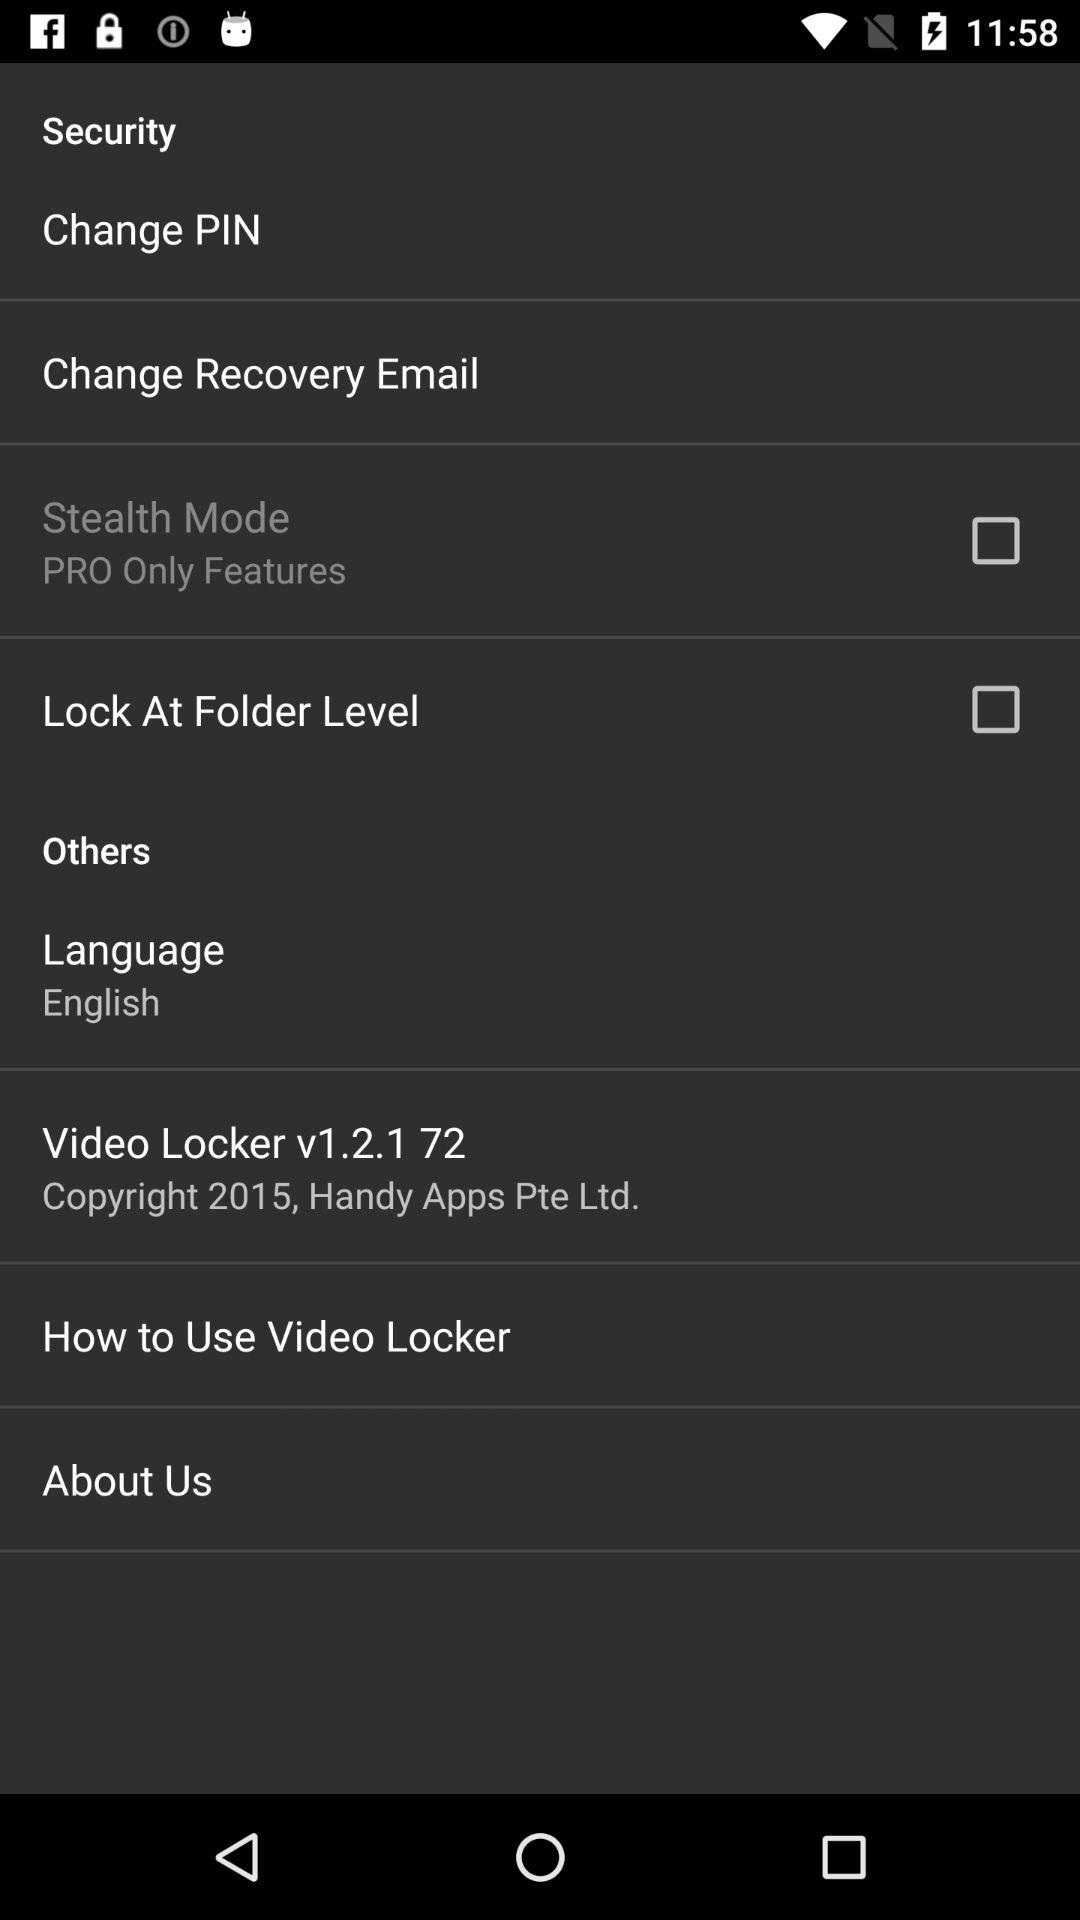What is the status of "Lock At Folder Level"? The status is "off". 